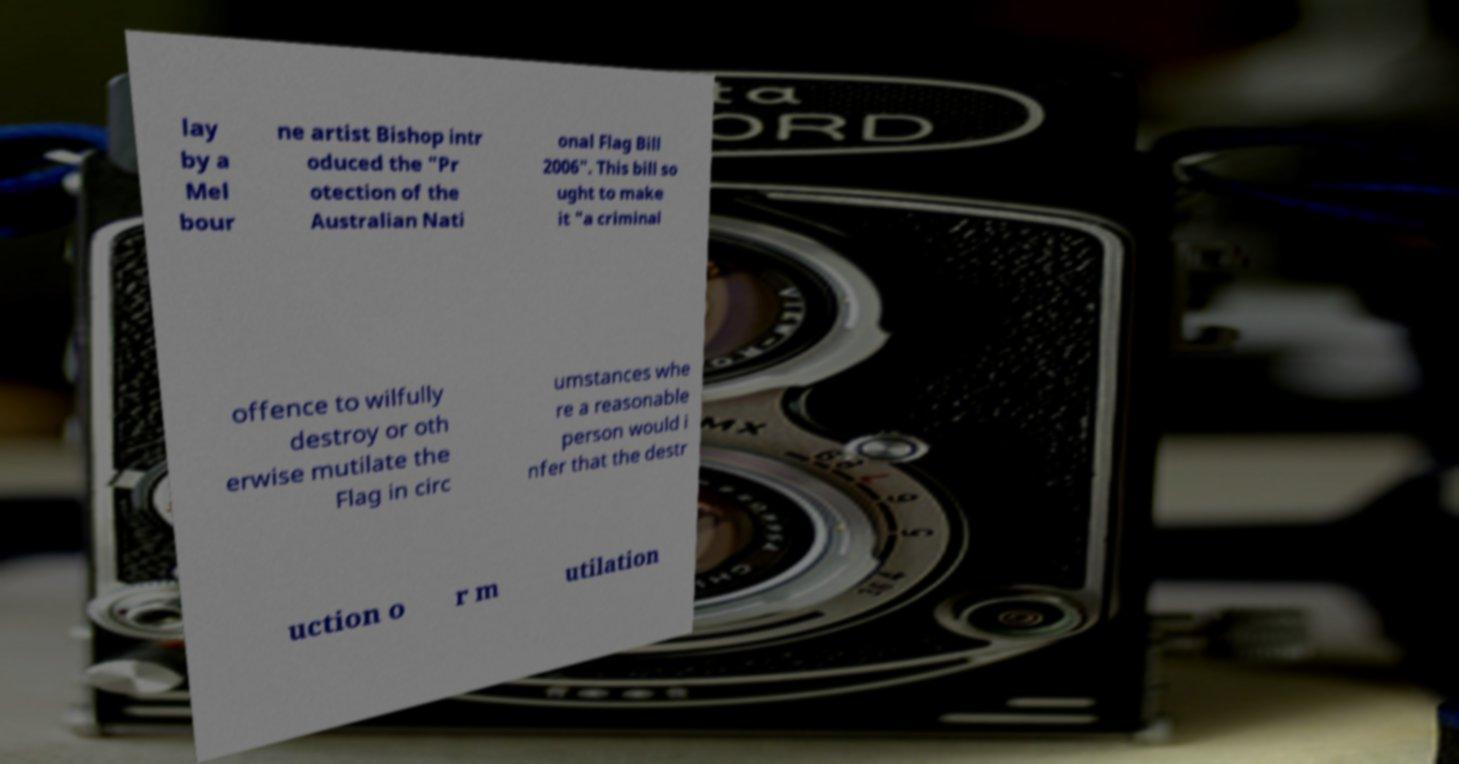Could you extract and type out the text from this image? lay by a Mel bour ne artist Bishop intr oduced the "Pr otection of the Australian Nati onal Flag Bill 2006". This bill so ught to make it "a criminal offence to wilfully destroy or oth erwise mutilate the Flag in circ umstances whe re a reasonable person would i nfer that the destr uction o r m utilation 